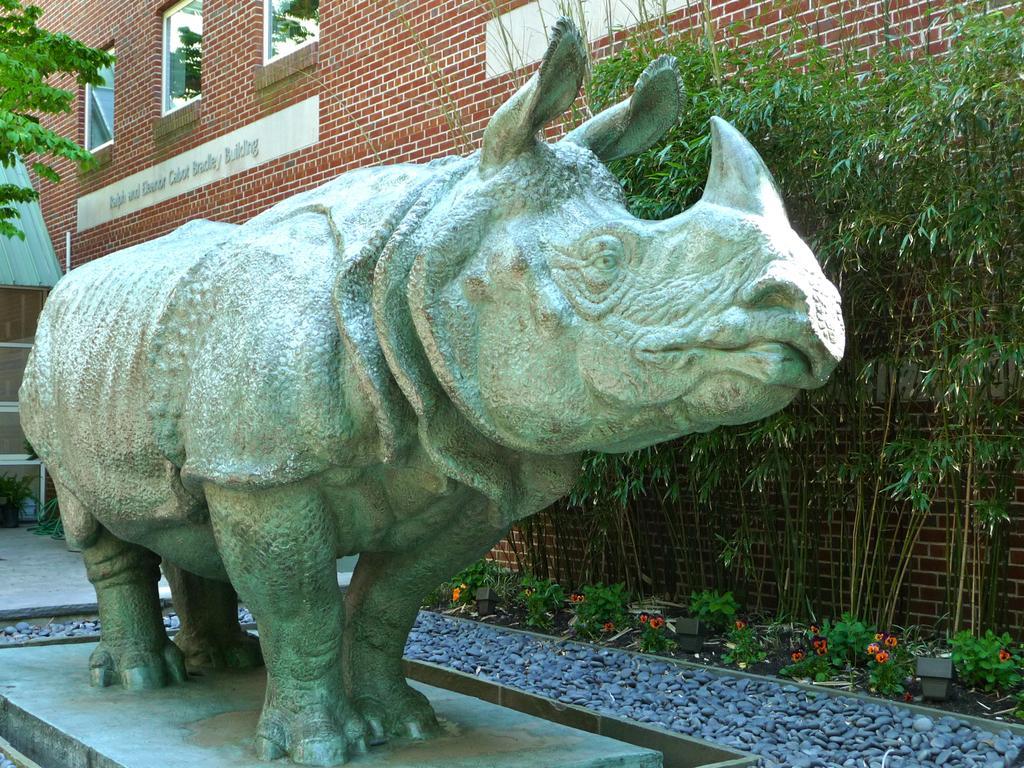Describe this image in one or two sentences. In this image there is a statue of rhino and some pebbles in the foreground. There are some plants in the right corner. There is a building with some text in the background. And there is a floor at the bottom. 